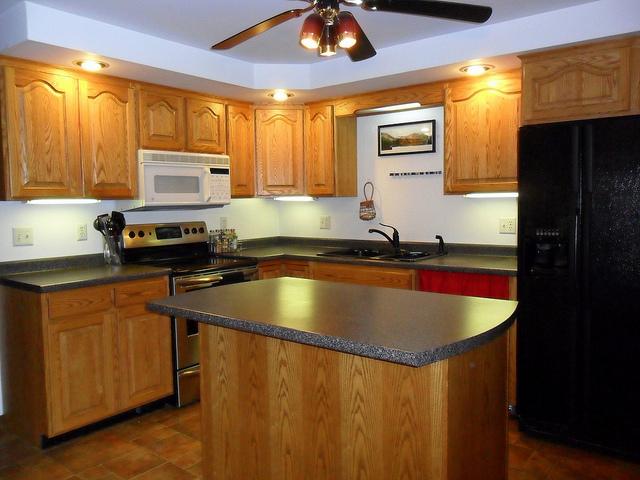Are the lights on?
Give a very brief answer. Yes. How many fan blades are shown?
Keep it brief. 3. What is the countertop made of?
Concise answer only. Marble. 